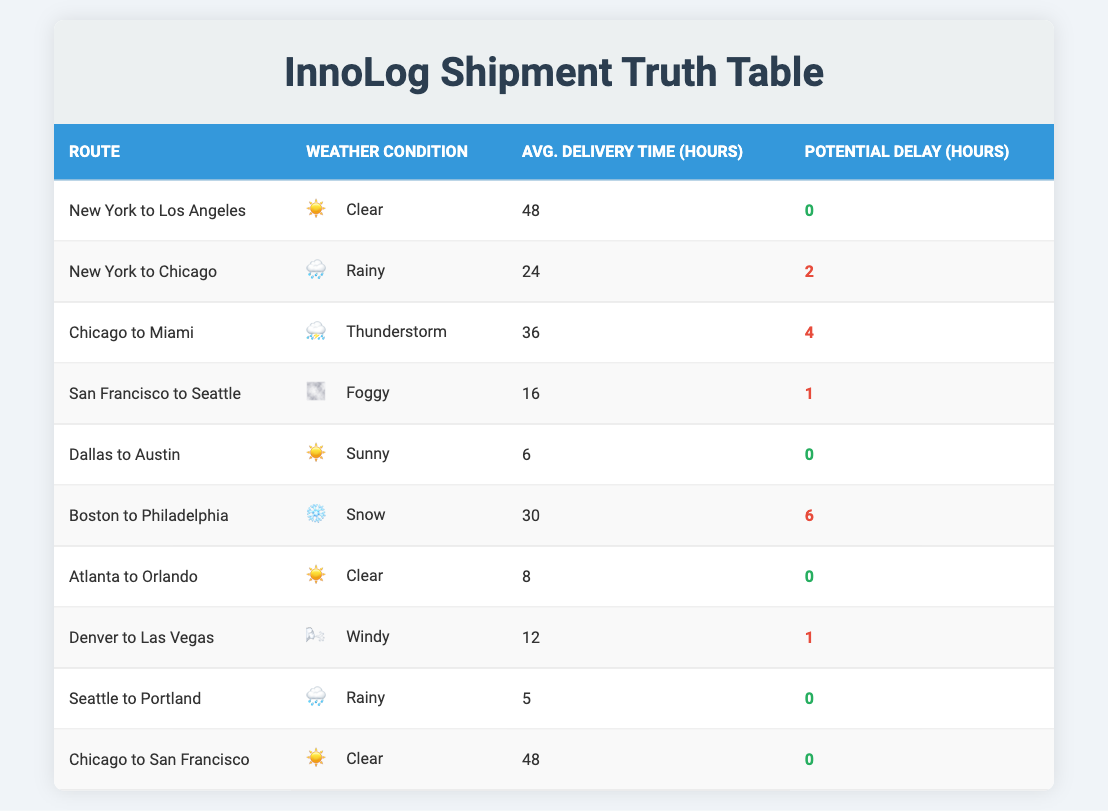What is the average delivery time for the route from New York to Los Angeles? The average delivery time for the route from New York to Los Angeles is directly listed in the table under "Avg. Delivery Time (hours)", which shows a value of 48 hours.
Answer: 48 hours How many routes experience a potential delay during delivery? By examining the "Potential Delay (hours)" column, I can identify the routes that have values greater than 0. There are 4 routes listed with potential delays: New York to Chicago (2 hours), Chicago to Miami (4 hours), San Francisco to Seattle (1 hour), and Boston to Philadelphia (6 hours).
Answer: 4 routes What is the total average delivery time for routes affected by rainy weather conditions? I will look for routes with "Rainy" listed under the "Weather Condition" column and find their average delivery time. The affected routes are New York to Chicago (24 hours) and Seattle to Portland (5 hours). The total average delivery time is (24 + 5) / 2 = 14.5 hours.
Answer: 14.5 hours Is there any route that has both an average delivery time under 10 hours and no potential delay? I will check for routes with an average delivery time under 10 hours. The only route fitting this description is Seattle to Portland (5 hours) which also has no potential delay (0 hours). Hence, the answer is yes.
Answer: Yes Which route has the maximum potential delay, and how long is it? To find the route with the maximum potential delay, I will compare the values in the "Potential Delay (hours)" column. The maximum delay value is 6 hours for the route Boston to Philadelphia.
Answer: Boston to Philadelphia, 6 hours What is the sum of the average delivery times for all routes with clear weather? I will look for routes under the "Weather Condition" column that are marked as "Clear". The relevant routes are New York to Los Angeles (48 hours) and Chicago to San Francisco (48 hours). The sum of these times is 48 + 48 = 96 hours.
Answer: 96 hours Do all routes with sunny weather conditions have no potential delays? I will check the potential delays for the routes listed under sunny weather. There are two sunny routes: Dallas to Austin (0 hours) and Atlanta to Orlando (0 hours), both showing no potential delays. Thus, it is true that all sunny routes have no potential delays.
Answer: Yes Which weather condition is associated with the route that has the shortest average delivery time? To find this, I will look at the "Avg. Delivery Time (hours)" column and identify the shortest time, which is 5 hours for the route Seattle to Portland. The associated weather condition for this route is "Rainy".
Answer: Rainy 